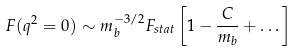Convert formula to latex. <formula><loc_0><loc_0><loc_500><loc_500>F ( q ^ { 2 } = 0 ) \sim { m _ { b } ^ { - 3 / 2 } } F _ { s t a t } \left [ 1 - \frac { C } { m _ { b } } + \dots \right ]</formula> 